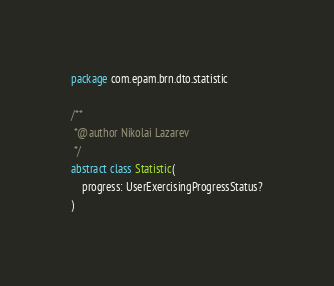<code> <loc_0><loc_0><loc_500><loc_500><_Kotlin_>package com.epam.brn.dto.statistic

/**
 *@author Nikolai Lazarev
 */
abstract class Statistic(
    progress: UserExercisingProgressStatus?
)
</code> 